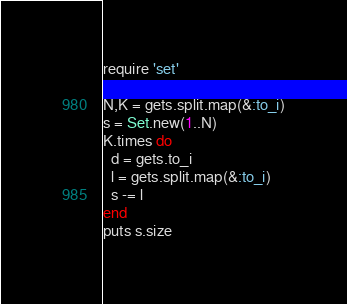<code> <loc_0><loc_0><loc_500><loc_500><_Ruby_>require 'set'

N,K = gets.split.map(&:to_i)
s = Set.new(1..N)
K.times do
  d = gets.to_i
  l = gets.split.map(&:to_i)
  s -= l
end
puts s.size</code> 